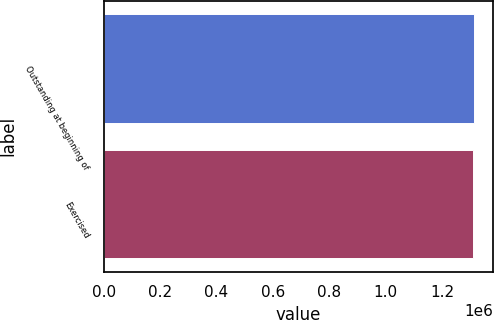Convert chart. <chart><loc_0><loc_0><loc_500><loc_500><bar_chart><fcel>Outstanding at beginning of<fcel>Exercised<nl><fcel>1.31406e+06<fcel>1.31068e+06<nl></chart> 